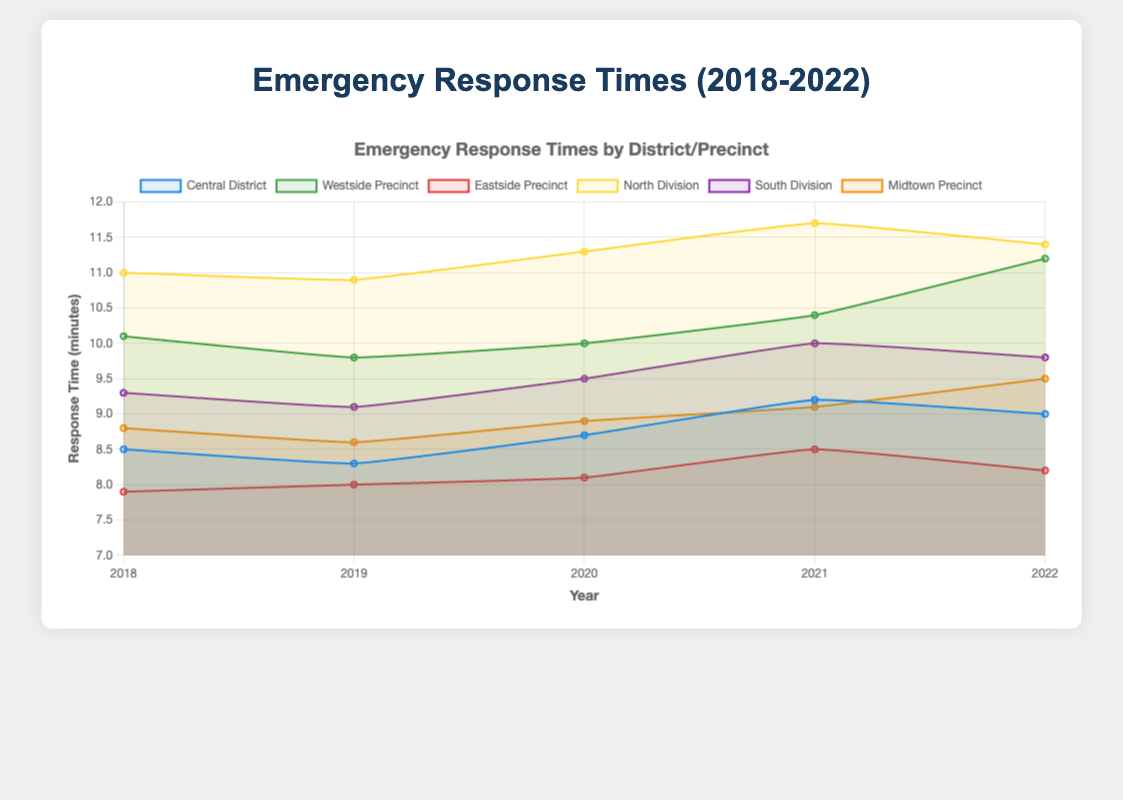Which district had the lowest response time in 2022? Observing the response times for each district in 2022, we see that the Eastside Precinct has the lowest time at 8.2 minutes.
Answer: Eastside Precinct How did the response time for the Westside Precinct change from 2018 to 2022? In 2018, the response time for the Westside Precinct was 10.1 minutes, while it was 11.2 minutes in 2022. The change is 11.2 - 10.1 = 1.1 minutes, indicating an increase.
Answer: Increased by 1.1 minutes Which division showed the most improvement in response times between 2018 and 2022? The Central District's response time went from 8.5 to 9.0, Westside Precinct from 10.1 to 11.2, Eastside Precinct from 7.9 to 8.2, North Division from 11.0 to 11.4, South Division from 9.3 to 9.8, and Midtown Precinct from 8.8 to 9.5. The Eastside Precinct improved the least, with a change from 7.9 to 8.2 minutes, so it shows improvement compared to others having increased more.
Answer: Eastside Precinct Which year had the highest overall response time for the North Division? Looking at the response times for the North Division, the highest response time was in 2021 with 11.7 minutes.
Answer: 2021 What is the average response time for the Central District from 2018 to 2022? The response times for the Central District are 8.5, 8.3, 8.7, 9.2, and 9.0. Summing these, we get 8.5 + 8.3 + 8.7 + 9.2 + 9.0 = 43.7. Dividing by 5, the average is 43.7 / 5 = 8.74 minutes.
Answer: 8.74 minutes Which precinct consistently had the highest response times throughout the five years? The North Division had the highest response times consistently for each year: 11.0, 10.9, 11.3, 11.7, and 11.4 minutes respectively.
Answer: North Division Compare the response time trends between the Central District and Midtown Precinct over the five years. Central District's response times were 8.5, 8.3, 8.7, 9.2, and 9.0, while Midtown Precinct's were 8.8, 8.6, 8.9, 9.1, and 9.5. Both show slight increases, but Midtown Precinct's response times generally increased more notably compared to the Central District.
Answer: Both increased, but Midtown Precinct increased more What was the response time difference between the North Division and the Eastside Precinct in 2022? In 2022, the North Division's response time was 11.4 minutes, and the Eastside Precinct's response time was 8.2 minutes. The difference is 11.4 - 8.2 = 3.2 minutes.
Answer: 3.2 minutes Between which years did the South Division see the greatest increase in response times? Looking at South Division's response times: 9.3, 9.1, 9.5, 10.0, 9.8, the greatest increase was between 2019 (9.1) and 2020 (9.5), an increase of 0.4 minutes.
Answer: 2019 to 2020 